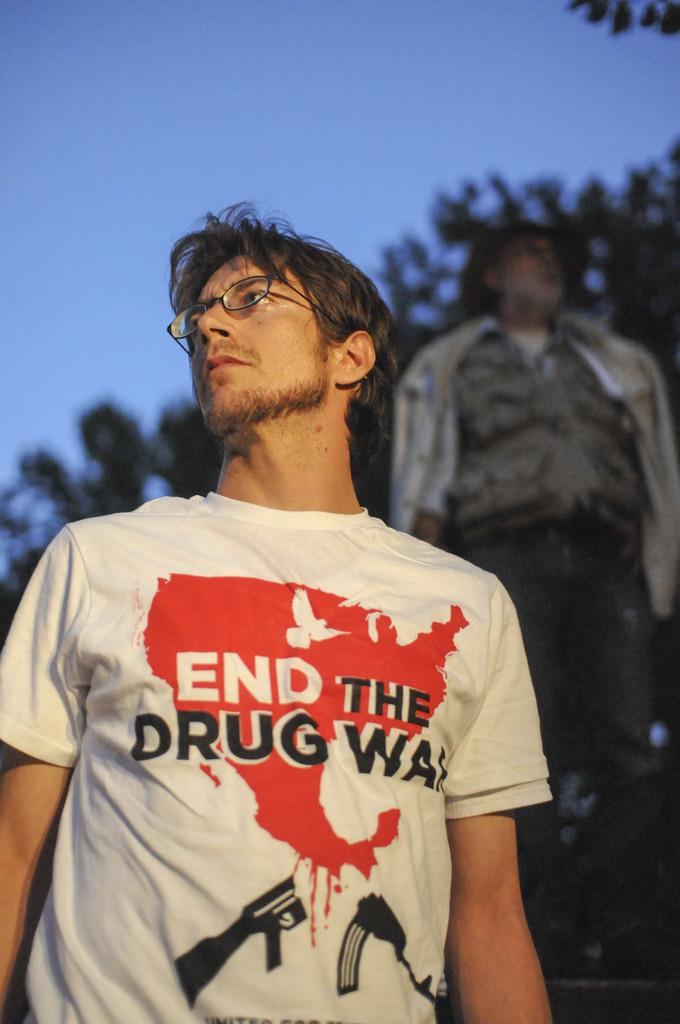How many people are in the image? There are two persons standing in the image. What is the person on the left wearing? The person on the left is wearing a white shirt. Does the person wearing a white shirt have any accessories? Yes, the person wearing a white shirt has spectacles. What can be seen in the background of the image? There is a group of trees and the sky visible in the background of the image. What type of zipper can be seen on the trees in the image? There are no zippers present on the trees in the image; they are natural vegetation. How many icicles are hanging from the person wearing a white shirt? There are no icicles present on the person wearing a white shirt or in the image. 